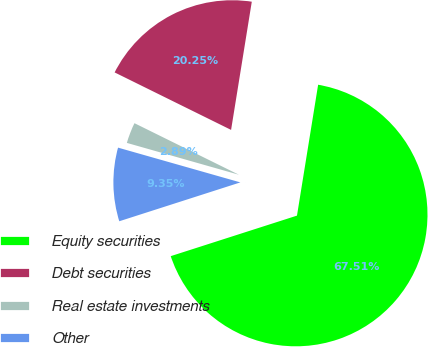Convert chart. <chart><loc_0><loc_0><loc_500><loc_500><pie_chart><fcel>Equity securities<fcel>Debt securities<fcel>Real estate investments<fcel>Other<nl><fcel>67.5%<fcel>20.25%<fcel>2.89%<fcel>9.35%<nl></chart> 